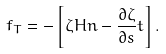<formula> <loc_0><loc_0><loc_500><loc_500>f _ { T } = - \left [ \zeta H n - \frac { \partial \zeta } { \partial s } t \right ] .</formula> 